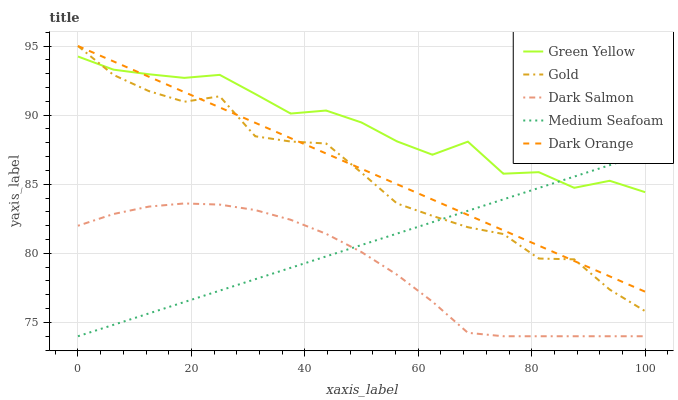Does Dark Salmon have the minimum area under the curve?
Answer yes or no. Yes. Does Green Yellow have the maximum area under the curve?
Answer yes or no. Yes. Does Green Yellow have the minimum area under the curve?
Answer yes or no. No. Does Dark Salmon have the maximum area under the curve?
Answer yes or no. No. Is Medium Seafoam the smoothest?
Answer yes or no. Yes. Is Green Yellow the roughest?
Answer yes or no. Yes. Is Dark Salmon the smoothest?
Answer yes or no. No. Is Dark Salmon the roughest?
Answer yes or no. No. Does Dark Salmon have the lowest value?
Answer yes or no. Yes. Does Green Yellow have the lowest value?
Answer yes or no. No. Does Gold have the highest value?
Answer yes or no. Yes. Does Green Yellow have the highest value?
Answer yes or no. No. Is Dark Salmon less than Gold?
Answer yes or no. Yes. Is Dark Orange greater than Dark Salmon?
Answer yes or no. Yes. Does Medium Seafoam intersect Dark Orange?
Answer yes or no. Yes. Is Medium Seafoam less than Dark Orange?
Answer yes or no. No. Is Medium Seafoam greater than Dark Orange?
Answer yes or no. No. Does Dark Salmon intersect Gold?
Answer yes or no. No. 